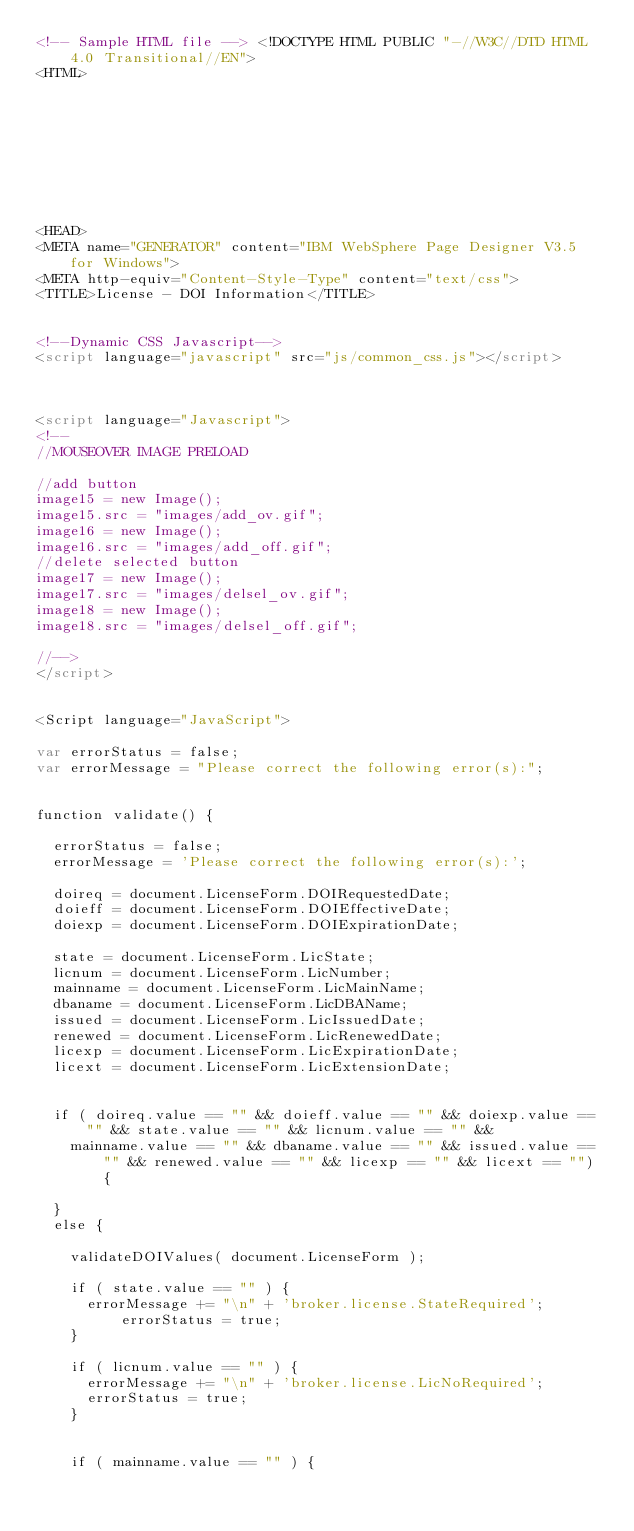<code> <loc_0><loc_0><loc_500><loc_500><_HTML_><!-- Sample HTML file --> <!DOCTYPE HTML PUBLIC "-//W3C//DTD HTML 4.0 Transitional//EN">
<HTML>









<HEAD>
<META name="GENERATOR" content="IBM WebSphere Page Designer V3.5 for Windows">
<META http-equiv="Content-Style-Type" content="text/css">
<TITLE>License - DOI Information</TITLE>


<!--Dynamic CSS Javascript-->
<script language="javascript" src="js/common_css.js"></script>



<script language="Javascript">
<!--
//MOUSEOVER IMAGE PRELOAD

//add button
image15 = new Image();
image15.src = "images/add_ov.gif";
image16 = new Image();
image16.src = "images/add_off.gif";
//delete selected button
image17 = new Image();
image17.src = "images/delsel_ov.gif";
image18 = new Image();
image18.src = "images/delsel_off.gif";

//-->
</script>


<Script language="JavaScript">

var errorStatus = false;
var errorMessage = "Please correct the following error(s):";


function validate() {
	
	errorStatus = false;
	errorMessage = 'Please correct the following error(s):';
	
	doireq = document.LicenseForm.DOIRequestedDate;
	doieff = document.LicenseForm.DOIEffectiveDate;
	doiexp = document.LicenseForm.DOIExpirationDate;

	state = document.LicenseForm.LicState;
	licnum = document.LicenseForm.LicNumber;
	mainname = document.LicenseForm.LicMainName;
	dbaname = document.LicenseForm.LicDBAName;
	issued = document.LicenseForm.LicIssuedDate;
	renewed = document.LicenseForm.LicRenewedDate;
	licexp = document.LicenseForm.LicExpirationDate;
	licext = document.LicenseForm.LicExtensionDate;


	if ( doireq.value == "" && doieff.value == "" && doiexp.value == "" && state.value == "" && licnum.value == "" &&
		mainname.value == "" && dbaname.value == "" && issued.value == "" && renewed.value == "" && licexp == "" && licext == "") {

	}
	else {

		validateDOIValues( document.LicenseForm );
	
		if ( state.value == "" ) {
			errorMessage += "\n" + 'broker.license.StateRequired';
		      errorStatus = true;
		}

		if ( licnum.value == "" ) {
			errorMessage += "\n" + 'broker.license.LicNoRequired';
			errorStatus = true;
		}

	
		if ( mainname.value == "" ) {</code> 